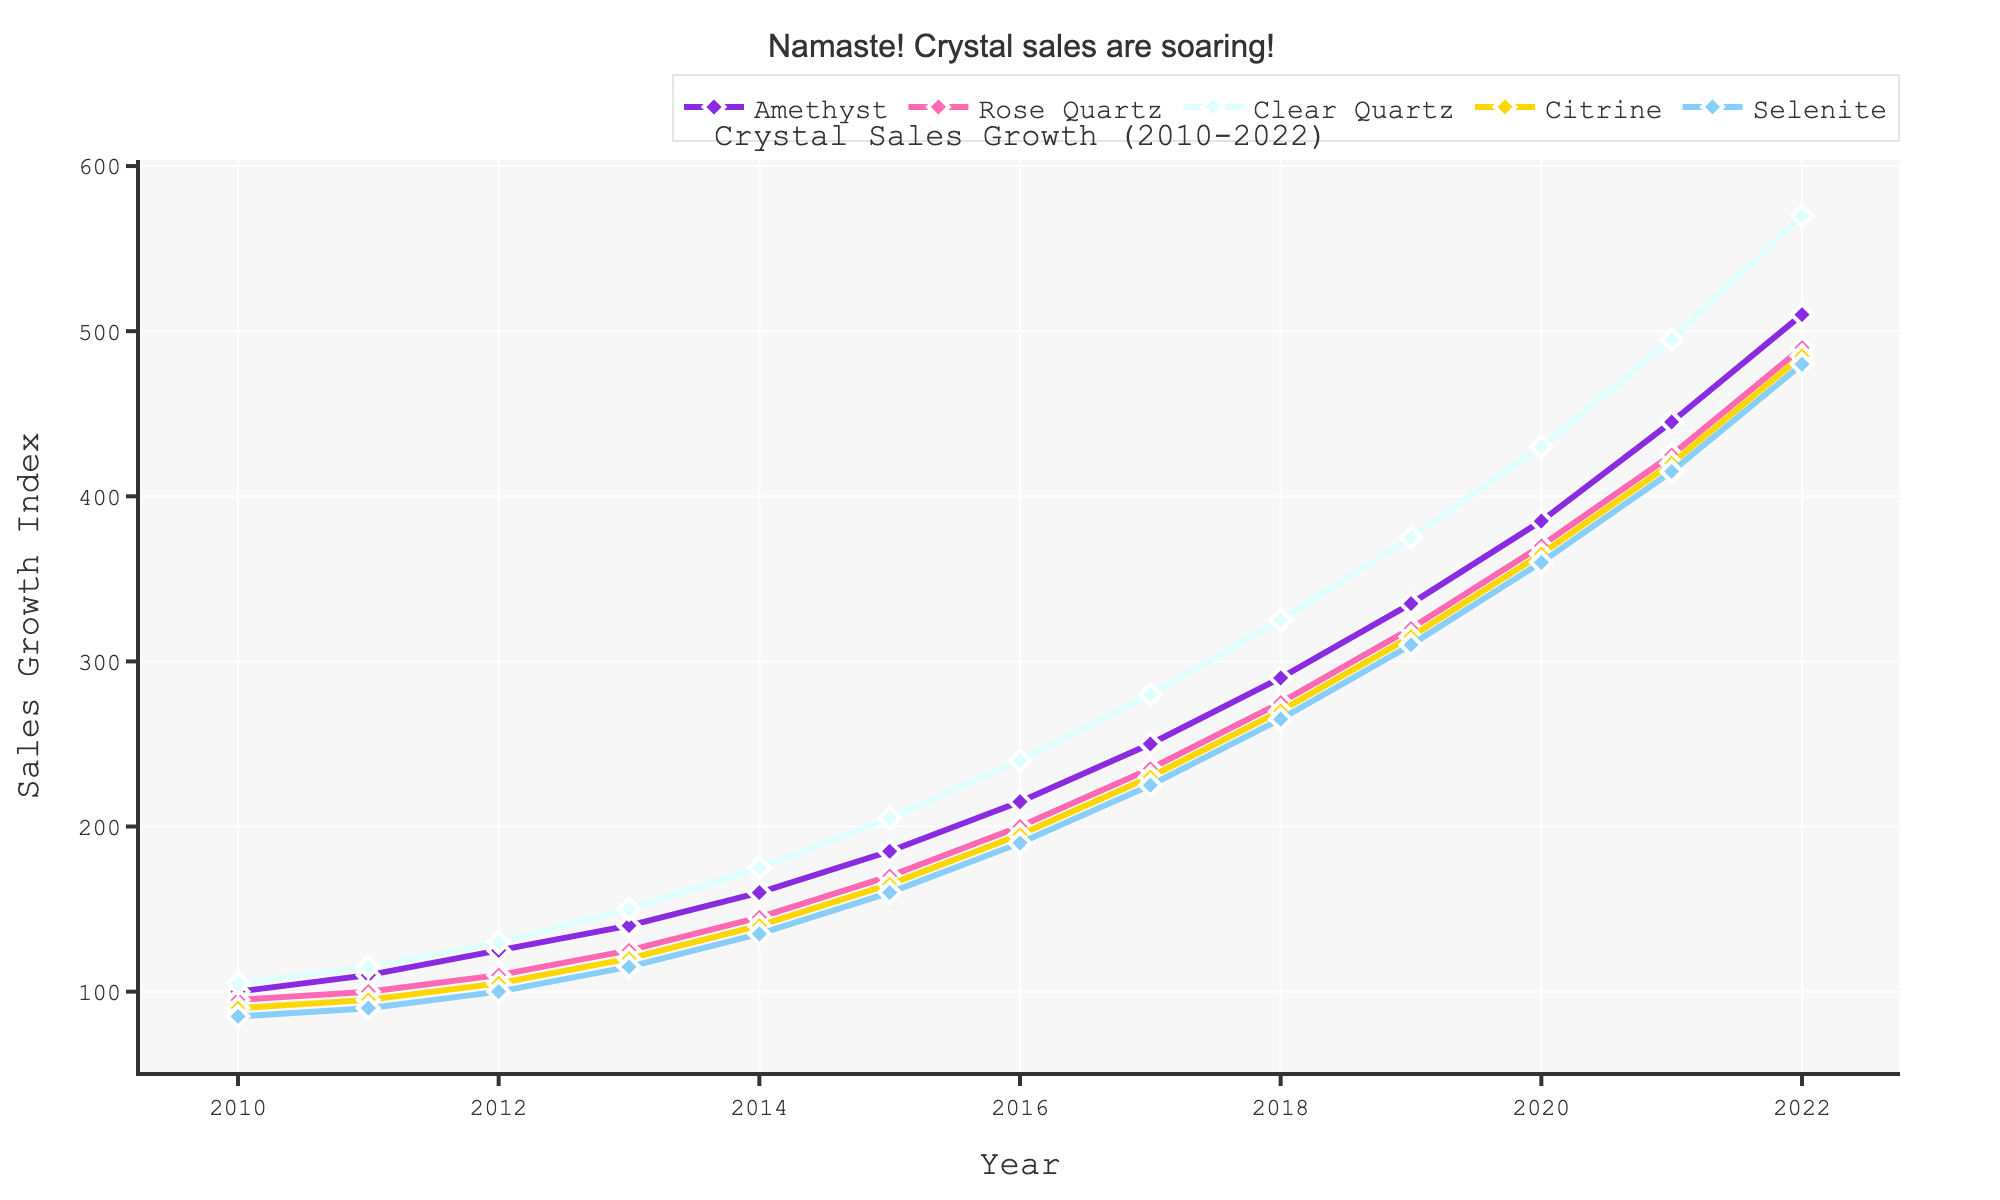What's the highest sales growth value for Amethyst and in which year did it occur? Look at the plot's line representing Amethyst and identify the highest point on the line. The highest value is 510, which occurs in 2022.
Answer: 510, 2022 How does the sales growth of Rose Quartz in 2022 compare to its growth in 2010? Compare the end value (2022) and the start value (2010) for Rose Quartz. In 2010, the value is 95, and in 2022, it's 490.
Answer: 490 is greater than 95 What is the average sales growth for Citrine from 2010 to 2015? Sum the sales growth values for Citrine from 2010 to 2015, which are 90, 95, 105, 120, 140, and 165. Then divide by the number of years (6). (90+95+105+120+140+165)/6 = 119.17
Answer: 119.17 Which crystal type had the most consistent sales growth over the years? Assess the lines for each crystal type by looking for the smoothest line without sharp increases or drops. Clear Quartz shows consistent growth without erratic changes.
Answer: Clear Quartz Between Selenite and Citrine, which had a higher sales growth increase from 2010 to 2022? Calculate the difference for each. For Selenite: 480-85 = 395. For Citrine: 485-90 = 395. Both crystal types have the same increase.
Answer: Both have an increase of 395 Between which consecutive years did Amethyst see the largest sales growth spike? Look at the changes year-by-year on Amethyst's line and identify the largest gap. From 2021 (445) to 2022 (510), the difference is 510 - 445 = 65, which is the largest.
Answer: 2021 to 2022 What is the total sales growth for Clear Quartz and Selenite in 2020? Refer to their respective sales growth values in the year 2020 and add them together. Clear Quartz: 430, Selenite: 360. Total = 430 + 360 = 790
Answer: 790 Which crystal's sales growth reached 375 first, and in which year? Look at each crystal's line on the plot. Citrine reached 375 in 2019.
Answer: Citrine, 2019 How does the growth trend for Clear Quartz compare visually to Rose Quartz over the entire period? Examine the shapes of the lines. Clear Quartz shows a steeper incline than Rose Quartz throughout the period, indicating faster growth.
Answer: Clear Quartz has a steeper incline 